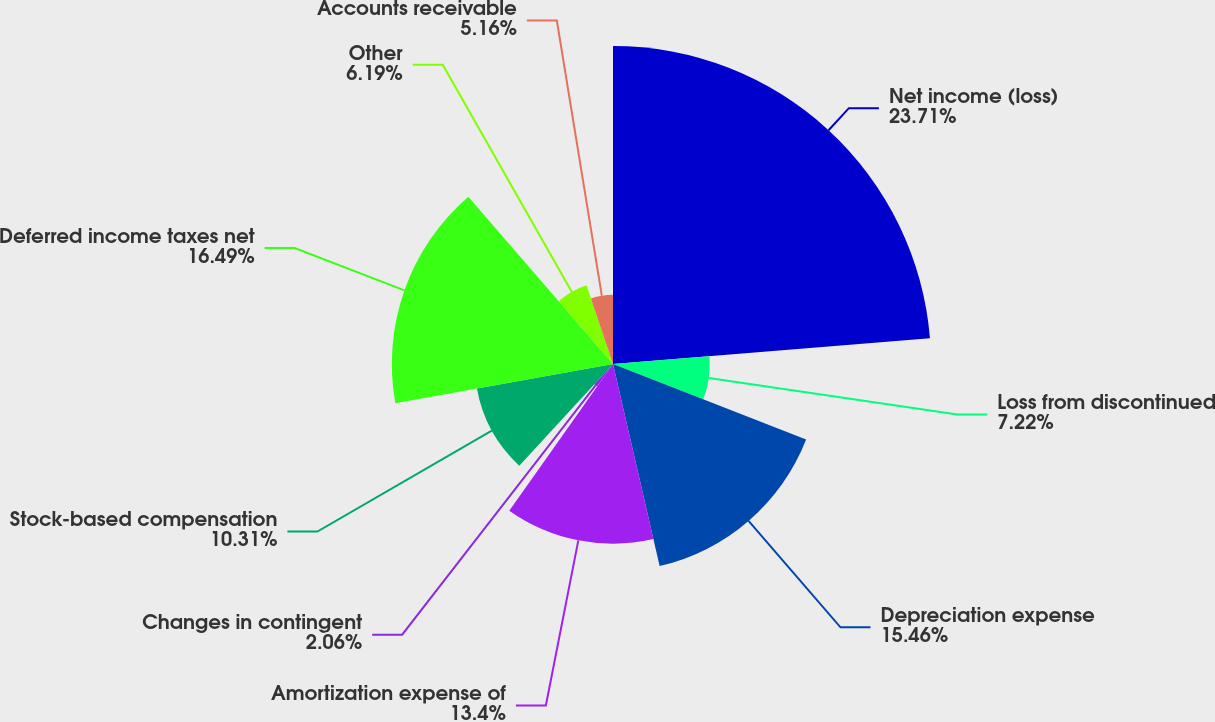Convert chart. <chart><loc_0><loc_0><loc_500><loc_500><pie_chart><fcel>Net income (loss)<fcel>Loss from discontinued<fcel>Depreciation expense<fcel>Amortization expense of<fcel>Changes in contingent<fcel>Stock-based compensation<fcel>Deferred income taxes net<fcel>Other<fcel>Accounts receivable<nl><fcel>23.71%<fcel>7.22%<fcel>15.46%<fcel>13.4%<fcel>2.06%<fcel>10.31%<fcel>16.49%<fcel>6.19%<fcel>5.16%<nl></chart> 